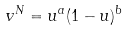Convert formula to latex. <formula><loc_0><loc_0><loc_500><loc_500>v ^ { N } = u ^ { a } ( 1 - u ) ^ { b }</formula> 